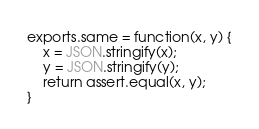Convert code to text. <code><loc_0><loc_0><loc_500><loc_500><_JavaScript_>
exports.same = function(x, y) {
    x = JSON.stringify(x);
    y = JSON.stringify(y);
    return assert.equal(x, y);
}
</code> 